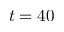<formula> <loc_0><loc_0><loc_500><loc_500>t = 4 0</formula> 